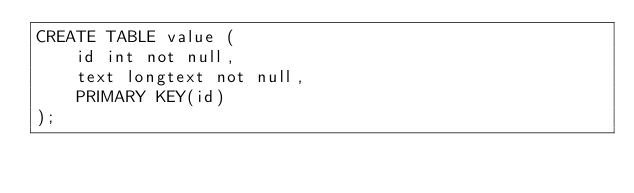Convert code to text. <code><loc_0><loc_0><loc_500><loc_500><_SQL_>CREATE TABLE value (
    id int not null,
    text longtext not null,
    PRIMARY KEY(id)
);
</code> 